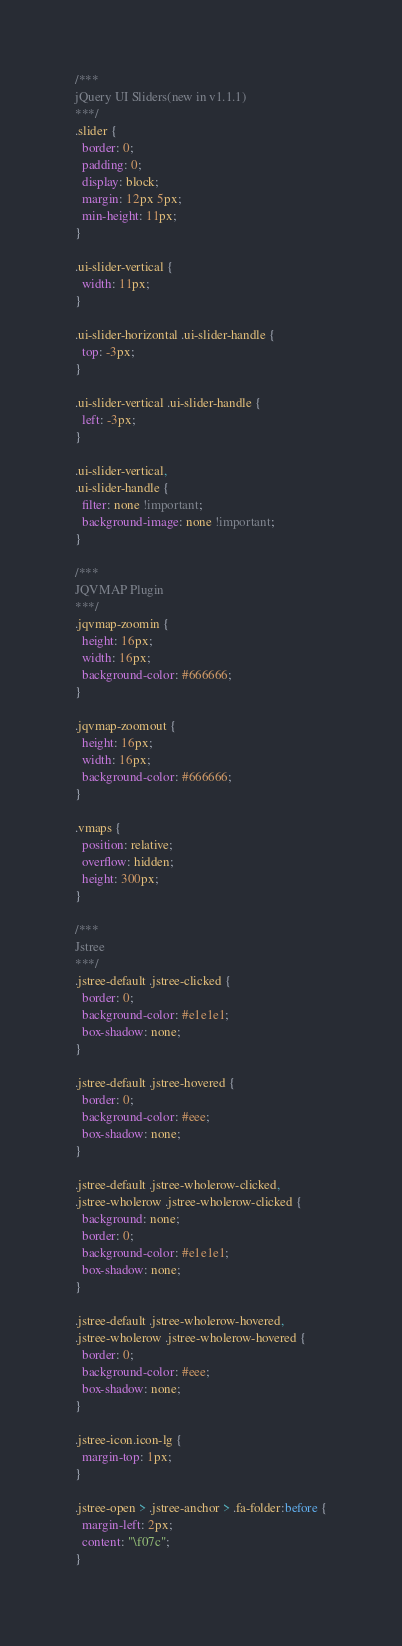<code> <loc_0><loc_0><loc_500><loc_500><_CSS_>/***
jQuery UI Sliders(new in v1.1.1)
***/
.slider {
  border: 0;
  padding: 0;
  display: block;
  margin: 12px 5px;
  min-height: 11px;
}

.ui-slider-vertical {
  width: 11px;
}

.ui-slider-horizontal .ui-slider-handle {
  top: -3px;
}

.ui-slider-vertical .ui-slider-handle {
  left: -3px;
}

.ui-slider-vertical,
.ui-slider-handle {
  filter: none !important;
  background-image: none !important;
}

/***
JQVMAP Plugin
***/
.jqvmap-zoomin {
  height: 16px;
  width: 16px;
  background-color: #666666;
}

.jqvmap-zoomout {
  height: 16px;
  width: 16px;
  background-color: #666666;
}

.vmaps {
  position: relative;
  overflow: hidden;
  height: 300px;
}

/***
Jstree
***/
.jstree-default .jstree-clicked {
  border: 0;
  background-color: #e1e1e1;
  box-shadow: none;
}

.jstree-default .jstree-hovered {
  border: 0;
  background-color: #eee;
  box-shadow: none;
}

.jstree-default .jstree-wholerow-clicked,
.jstree-wholerow .jstree-wholerow-clicked {
  background: none;
  border: 0;
  background-color: #e1e1e1;
  box-shadow: none;
}

.jstree-default .jstree-wholerow-hovered,
.jstree-wholerow .jstree-wholerow-hovered {
  border: 0;
  background-color: #eee;
  box-shadow: none;
}

.jstree-icon.icon-lg {
  margin-top: 1px;
}

.jstree-open > .jstree-anchor > .fa-folder:before {
  margin-left: 2px;
  content: "\f07c";
}
</code> 